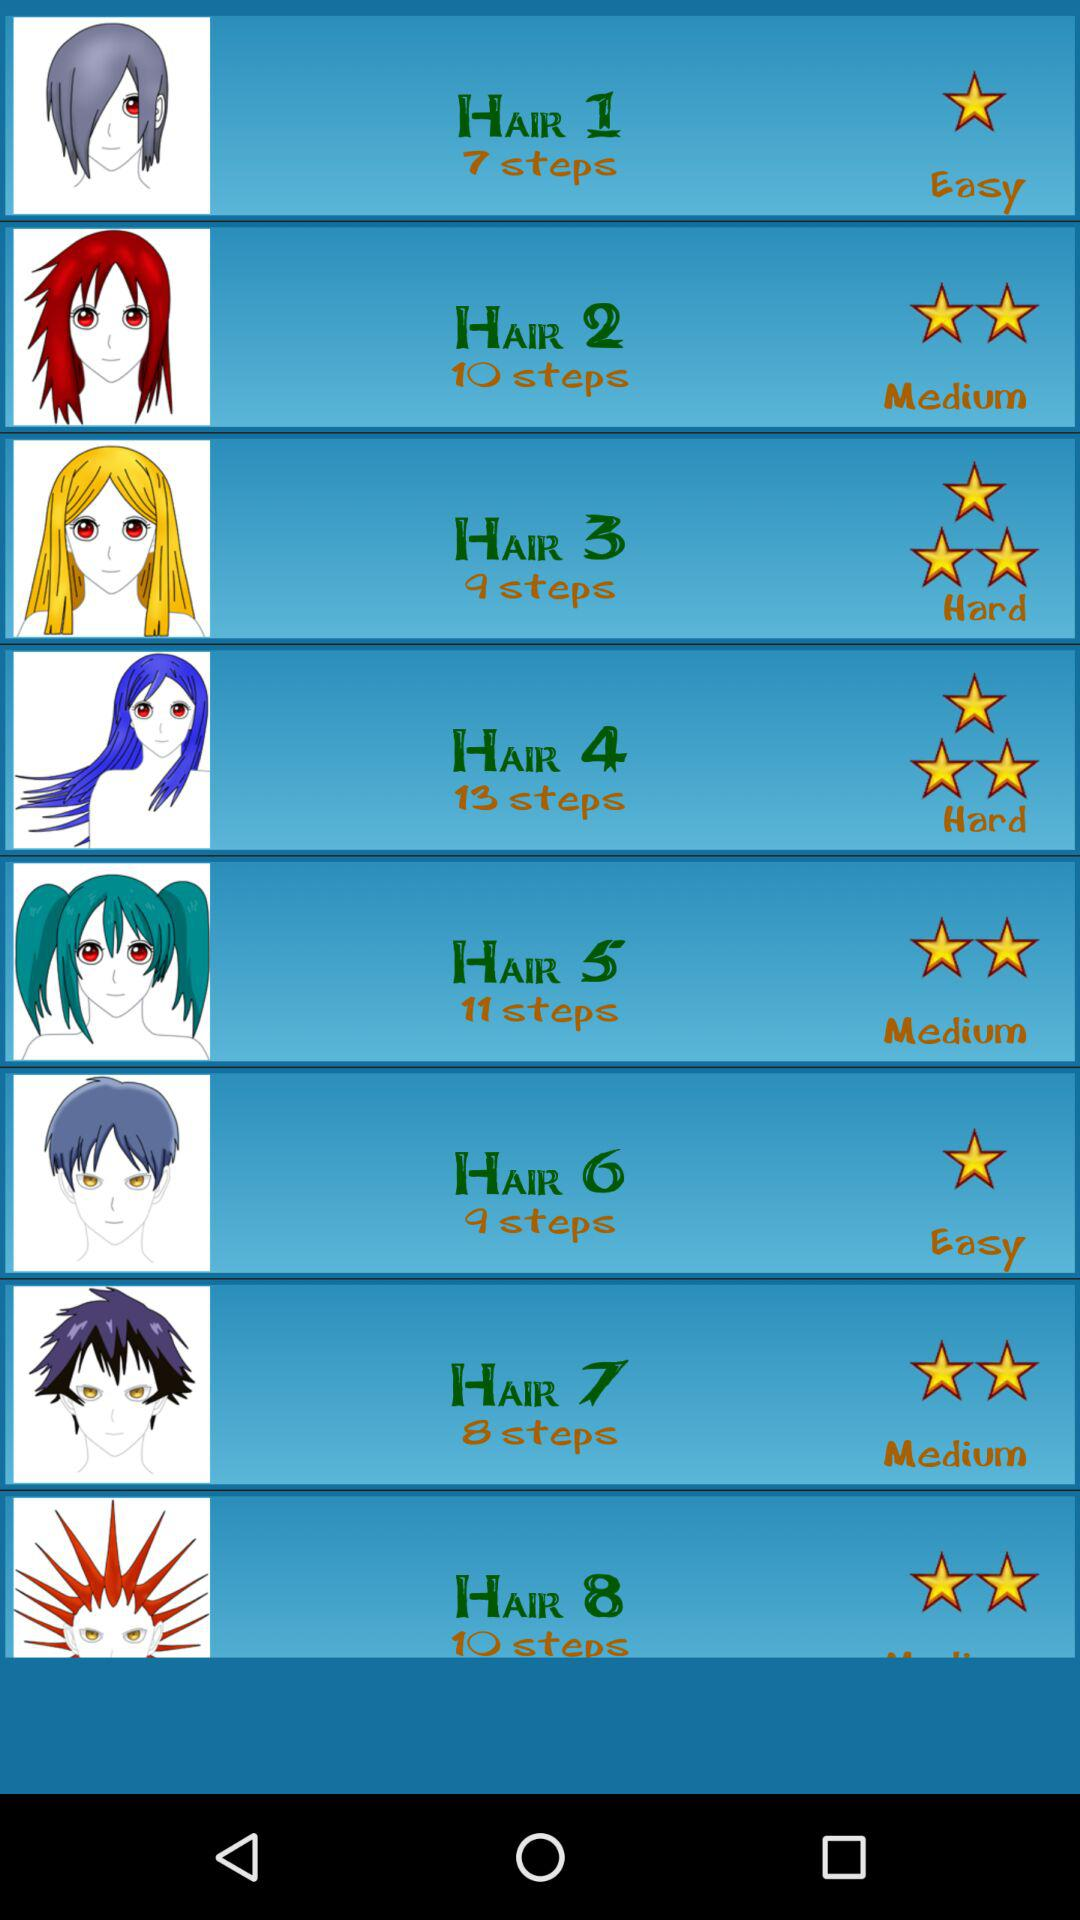How many steps are there in "Hair 1"? There are 7 steps in "Hair 1". 